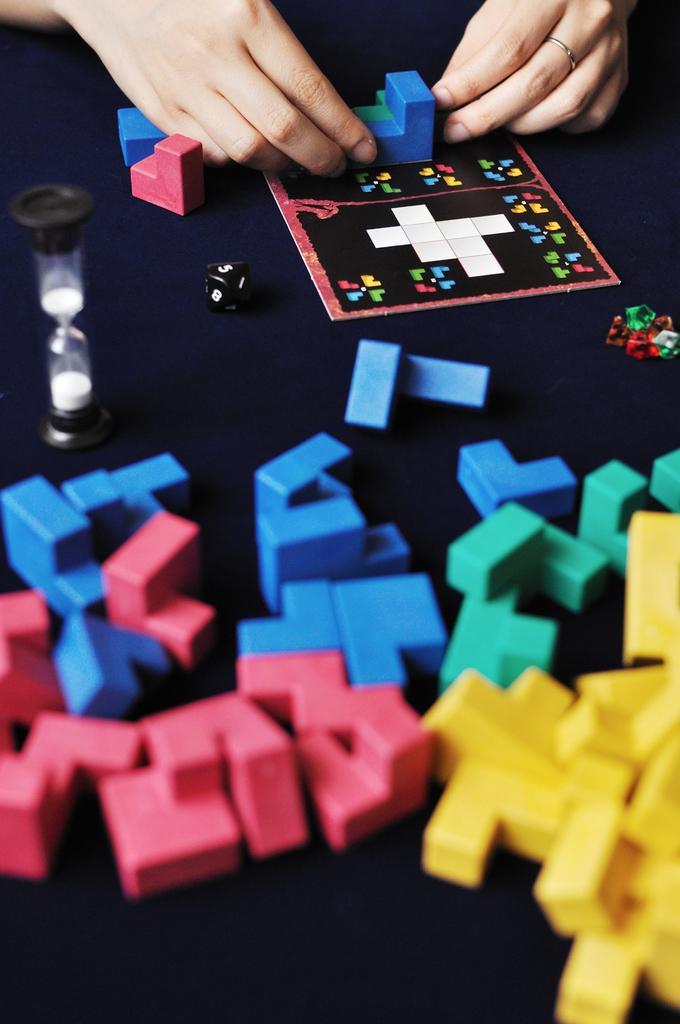In one or two sentences, can you explain what this image depicts? In this image there are objects on the surface, there are objects truncated towards the right of the image, there are objects truncated towards the left of the image, there is a person hand truncated towards the top of the image. 